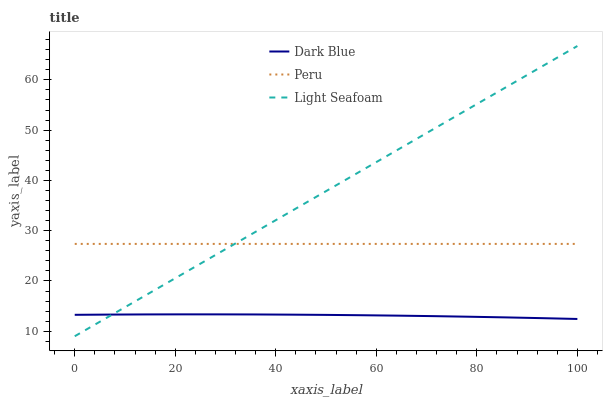Does Peru have the minimum area under the curve?
Answer yes or no. No. Does Peru have the maximum area under the curve?
Answer yes or no. No. Is Peru the smoothest?
Answer yes or no. No. Is Peru the roughest?
Answer yes or no. No. Does Peru have the lowest value?
Answer yes or no. No. Does Peru have the highest value?
Answer yes or no. No. Is Dark Blue less than Peru?
Answer yes or no. Yes. Is Peru greater than Dark Blue?
Answer yes or no. Yes. Does Dark Blue intersect Peru?
Answer yes or no. No. 